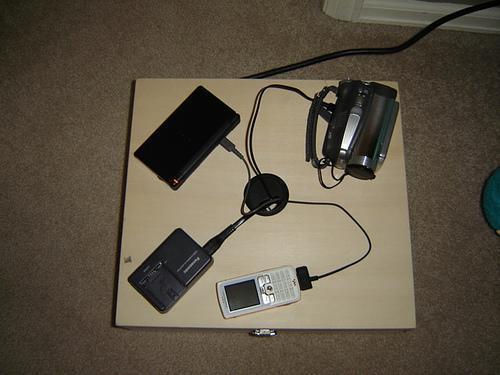How many devices are being charged?
Give a very brief answer. 4. How many plugs are on the board?
Give a very brief answer. 4. How many cell phones are in the photo?
Give a very brief answer. 2. 